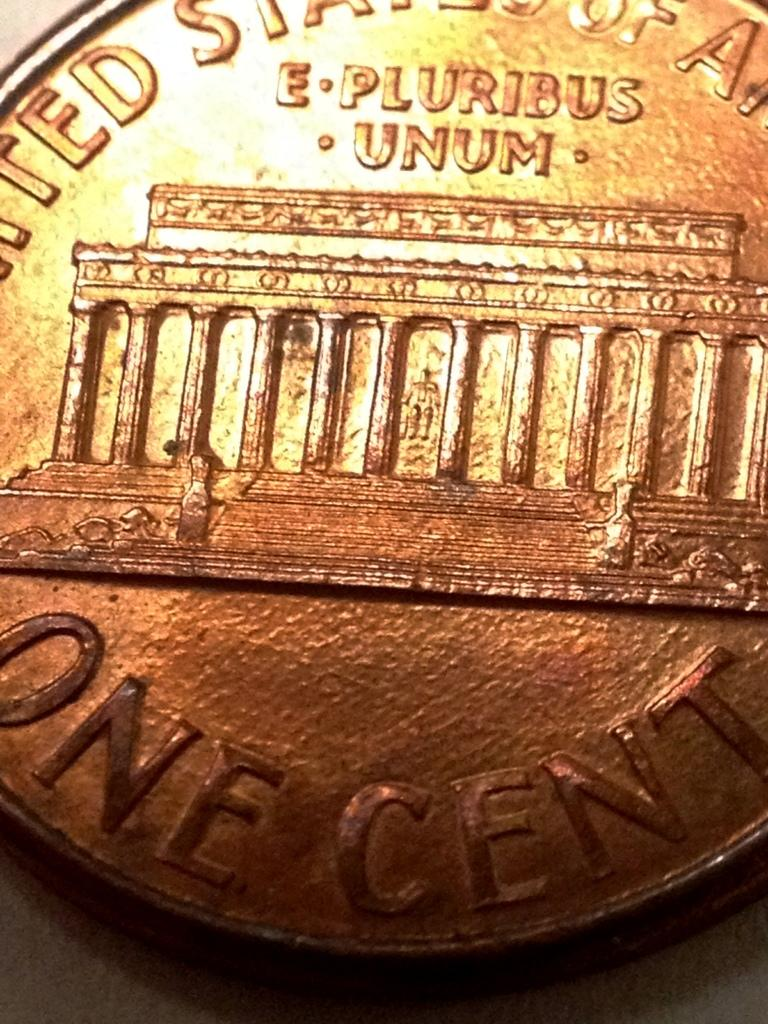Provide a one-sentence caption for the provided image. a copper coin that says one cent on the bottom of it. 